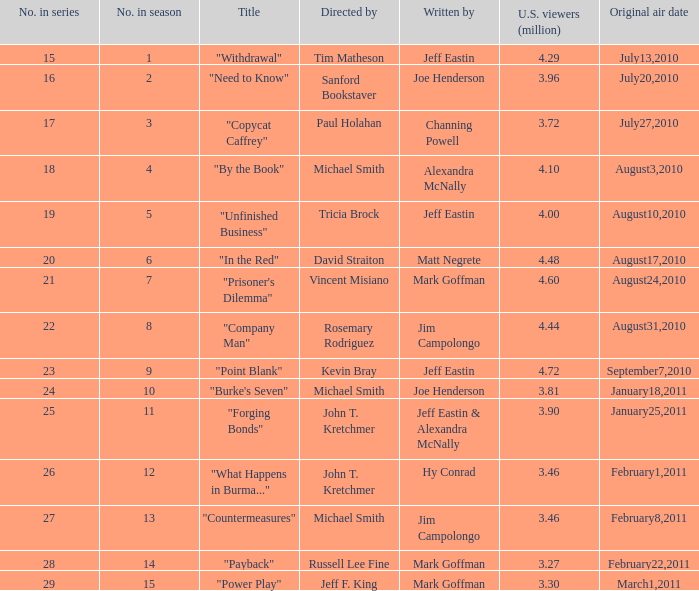Can you give me this table as a dict? {'header': ['No. in series', 'No. in season', 'Title', 'Directed by', 'Written by', 'U.S. viewers (million)', 'Original air date'], 'rows': [['15', '1', '"Withdrawal"', 'Tim Matheson', 'Jeff Eastin', '4.29', 'July13,2010'], ['16', '2', '"Need to Know"', 'Sanford Bookstaver', 'Joe Henderson', '3.96', 'July20,2010'], ['17', '3', '"Copycat Caffrey"', 'Paul Holahan', 'Channing Powell', '3.72', 'July27,2010'], ['18', '4', '"By the Book"', 'Michael Smith', 'Alexandra McNally', '4.10', 'August3,2010'], ['19', '5', '"Unfinished Business"', 'Tricia Brock', 'Jeff Eastin', '4.00', 'August10,2010'], ['20', '6', '"In the Red"', 'David Straiton', 'Matt Negrete', '4.48', 'August17,2010'], ['21', '7', '"Prisoner\'s Dilemma"', 'Vincent Misiano', 'Mark Goffman', '4.60', 'August24,2010'], ['22', '8', '"Company Man"', 'Rosemary Rodriguez', 'Jim Campolongo', '4.44', 'August31,2010'], ['23', '9', '"Point Blank"', 'Kevin Bray', 'Jeff Eastin', '4.72', 'September7,2010'], ['24', '10', '"Burke\'s Seven"', 'Michael Smith', 'Joe Henderson', '3.81', 'January18,2011'], ['25', '11', '"Forging Bonds"', 'John T. Kretchmer', 'Jeff Eastin & Alexandra McNally', '3.90', 'January25,2011'], ['26', '12', '"What Happens in Burma..."', 'John T. Kretchmer', 'Hy Conrad', '3.46', 'February1,2011'], ['27', '13', '"Countermeasures"', 'Michael Smith', 'Jim Campolongo', '3.46', 'February8,2011'], ['28', '14', '"Payback"', 'Russell Lee Fine', 'Mark Goffman', '3.27', 'February22,2011'], ['29', '15', '"Power Play"', 'Jeff F. King', 'Mark Goffman', '3.30', 'March1,2011']]} Who helmed the episode "point blank"? Kevin Bray. 